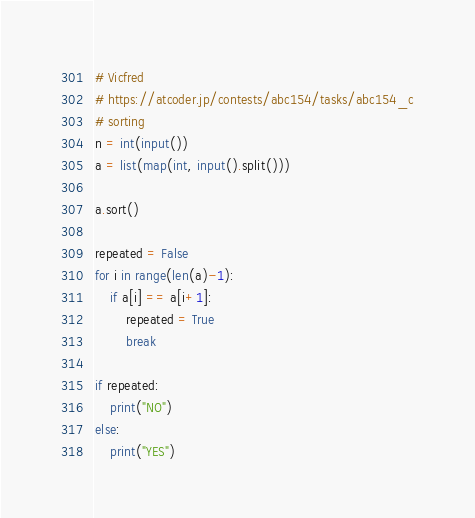<code> <loc_0><loc_0><loc_500><loc_500><_Python_># Vicfred
# https://atcoder.jp/contests/abc154/tasks/abc154_c
# sorting
n = int(input())
a = list(map(int, input().split()))

a.sort()

repeated = False
for i in range(len(a)-1):
    if a[i] == a[i+1]:
        repeated = True
        break

if repeated:
    print("NO")
else:
    print("YES")

</code> 